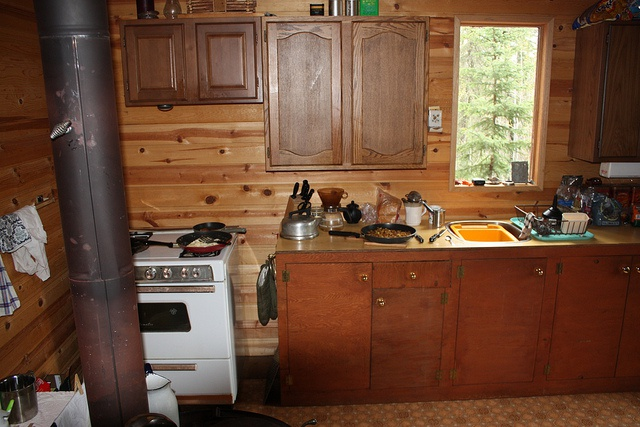Describe the objects in this image and their specific colors. I can see oven in black, darkgray, lightgray, and gray tones, sink in black, orange, ivory, khaki, and maroon tones, cup in black, darkgray, lightgray, and gray tones, knife in black, gray, maroon, and tan tones, and knife in black, maroon, and tan tones in this image. 